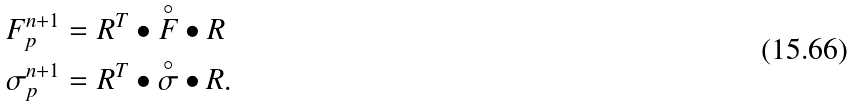Convert formula to latex. <formula><loc_0><loc_0><loc_500><loc_500>F _ { p } ^ { n + 1 } & = R ^ { T } \bullet \overset { \circ } { F } \bullet R \\ \sigma _ { p } ^ { n + 1 } & = R ^ { T } \bullet \overset { \circ } { \sigma } \bullet R .</formula> 